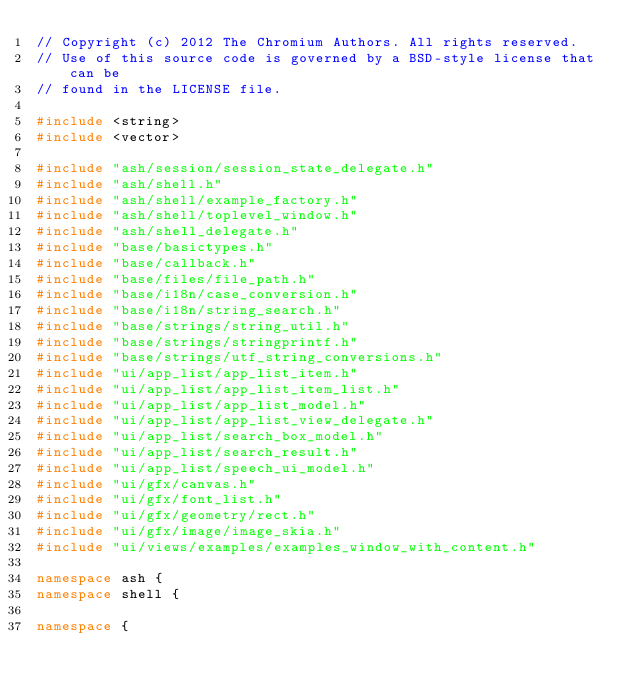Convert code to text. <code><loc_0><loc_0><loc_500><loc_500><_C++_>// Copyright (c) 2012 The Chromium Authors. All rights reserved.
// Use of this source code is governed by a BSD-style license that can be
// found in the LICENSE file.

#include <string>
#include <vector>

#include "ash/session/session_state_delegate.h"
#include "ash/shell.h"
#include "ash/shell/example_factory.h"
#include "ash/shell/toplevel_window.h"
#include "ash/shell_delegate.h"
#include "base/basictypes.h"
#include "base/callback.h"
#include "base/files/file_path.h"
#include "base/i18n/case_conversion.h"
#include "base/i18n/string_search.h"
#include "base/strings/string_util.h"
#include "base/strings/stringprintf.h"
#include "base/strings/utf_string_conversions.h"
#include "ui/app_list/app_list_item.h"
#include "ui/app_list/app_list_item_list.h"
#include "ui/app_list/app_list_model.h"
#include "ui/app_list/app_list_view_delegate.h"
#include "ui/app_list/search_box_model.h"
#include "ui/app_list/search_result.h"
#include "ui/app_list/speech_ui_model.h"
#include "ui/gfx/canvas.h"
#include "ui/gfx/font_list.h"
#include "ui/gfx/geometry/rect.h"
#include "ui/gfx/image/image_skia.h"
#include "ui/views/examples/examples_window_with_content.h"

namespace ash {
namespace shell {

namespace {
</code> 